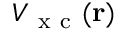<formula> <loc_0><loc_0><loc_500><loc_500>V _ { x c } ( r )</formula> 